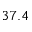<formula> <loc_0><loc_0><loc_500><loc_500>3 7 . 4</formula> 